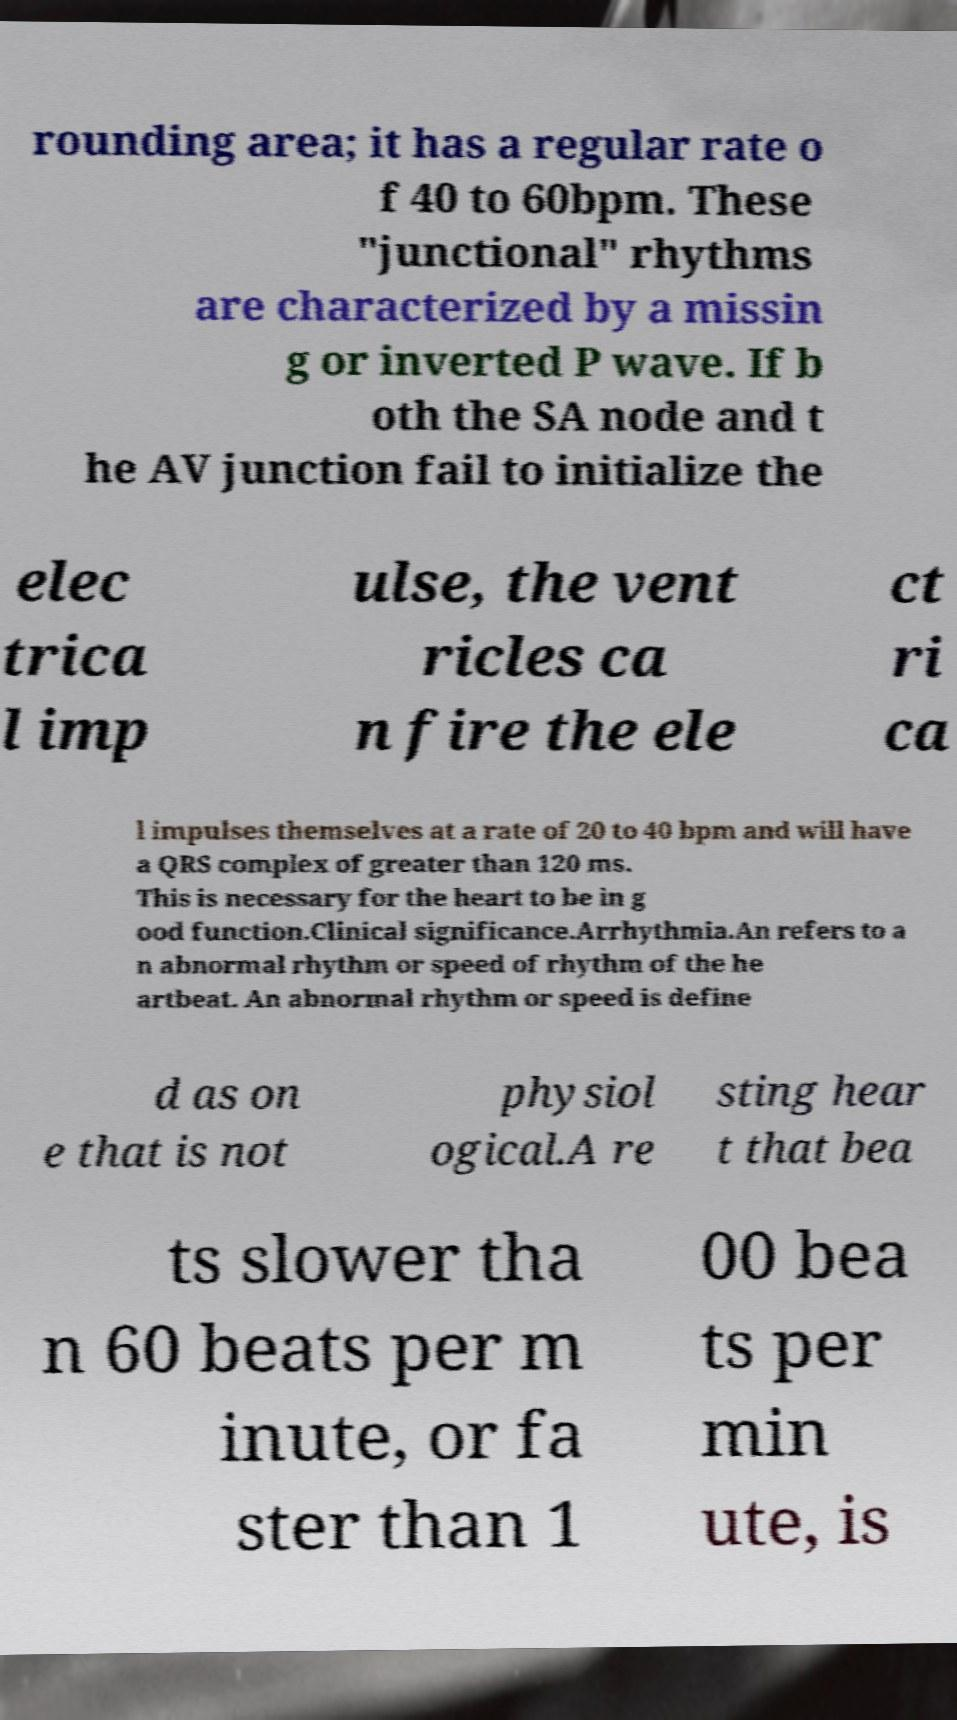Could you assist in decoding the text presented in this image and type it out clearly? rounding area; it has a regular rate o f 40 to 60bpm. These "junctional" rhythms are characterized by a missin g or inverted P wave. If b oth the SA node and t he AV junction fail to initialize the elec trica l imp ulse, the vent ricles ca n fire the ele ct ri ca l impulses themselves at a rate of 20 to 40 bpm and will have a QRS complex of greater than 120 ms. This is necessary for the heart to be in g ood function.Clinical significance.Arrhythmia.An refers to a n abnormal rhythm or speed of rhythm of the he artbeat. An abnormal rhythm or speed is define d as on e that is not physiol ogical.A re sting hear t that bea ts slower tha n 60 beats per m inute, or fa ster than 1 00 bea ts per min ute, is 